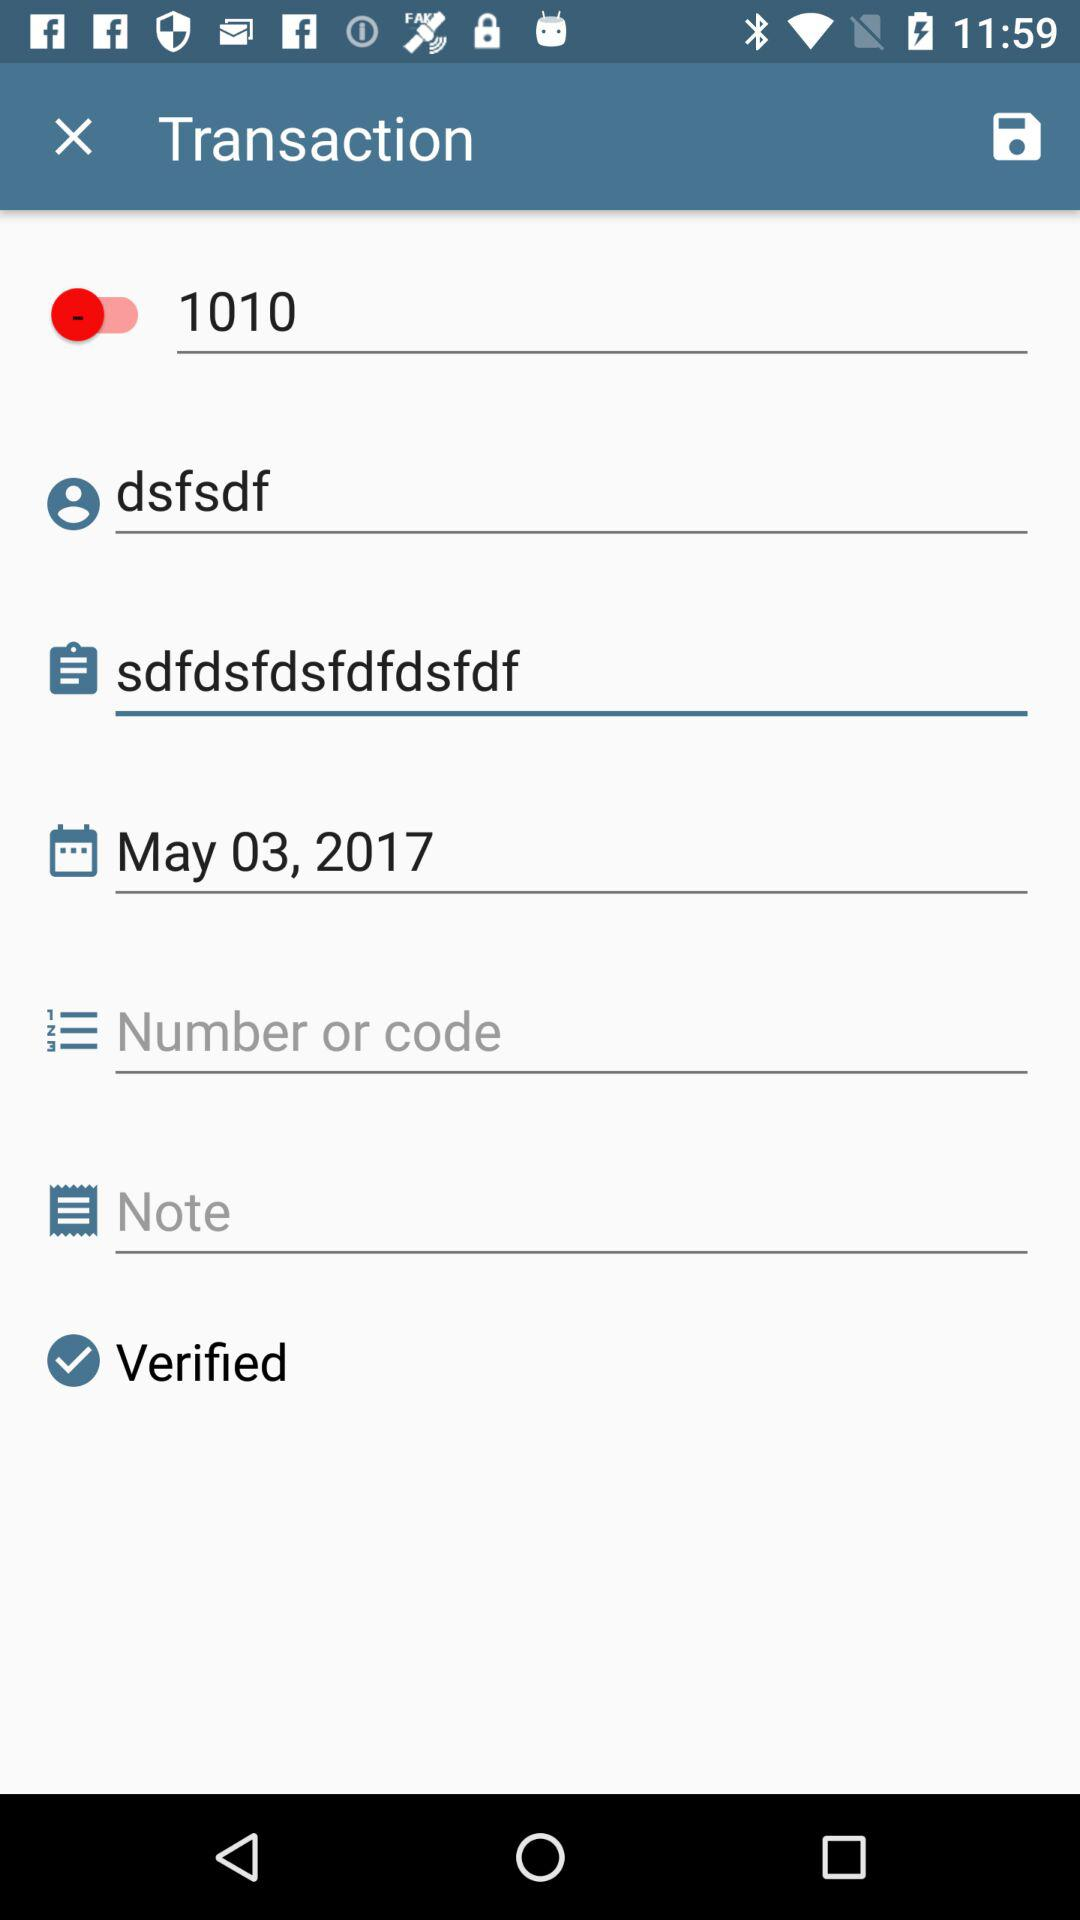Is the transaction verified or not? The transaction is verified. 